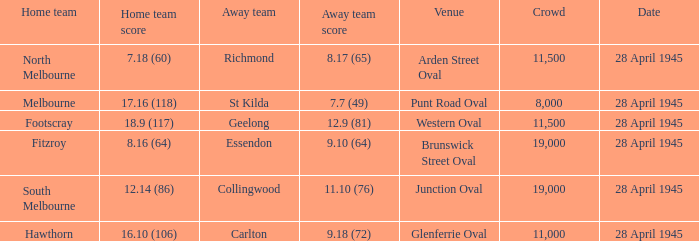What guest team played at western oval? Geelong. 